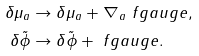<formula> <loc_0><loc_0><loc_500><loc_500>\delta \mu _ { a } & \rightarrow \delta \mu _ { a } + \nabla _ { a } \ f g a u g e , \\ \delta \tilde { \phi } & \rightarrow \delta \tilde { \phi } + \ f g a u g e .</formula> 